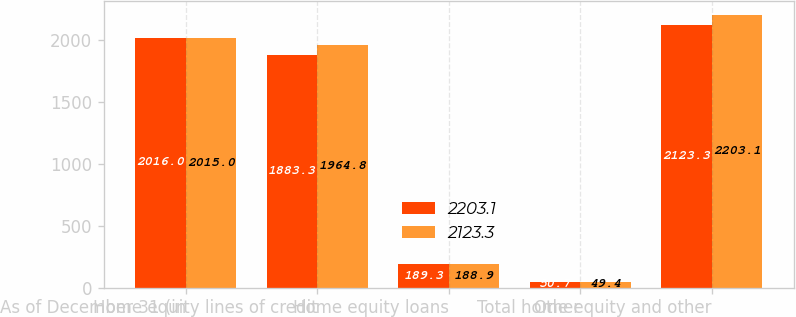<chart> <loc_0><loc_0><loc_500><loc_500><stacked_bar_chart><ecel><fcel>As of December 31 (in<fcel>Home equity lines of credit<fcel>Home equity loans<fcel>Other<fcel>Total home equity and other<nl><fcel>2203.1<fcel>2016<fcel>1883.3<fcel>189.3<fcel>50.7<fcel>2123.3<nl><fcel>2123.3<fcel>2015<fcel>1964.8<fcel>188.9<fcel>49.4<fcel>2203.1<nl></chart> 